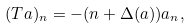<formula> <loc_0><loc_0><loc_500><loc_500>( T a ) _ { n } = - ( n + \Delta ( a ) ) a _ { n } ,</formula> 